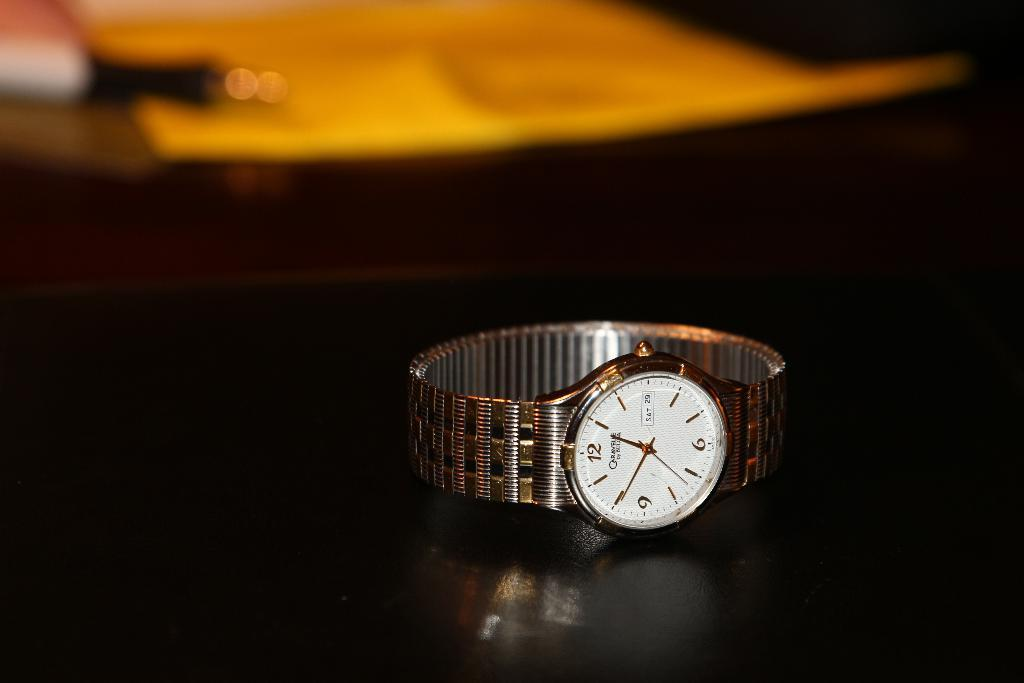<image>
Write a terse but informative summary of the picture. A silver colored watch that shows it to be Saturday the 29th. 